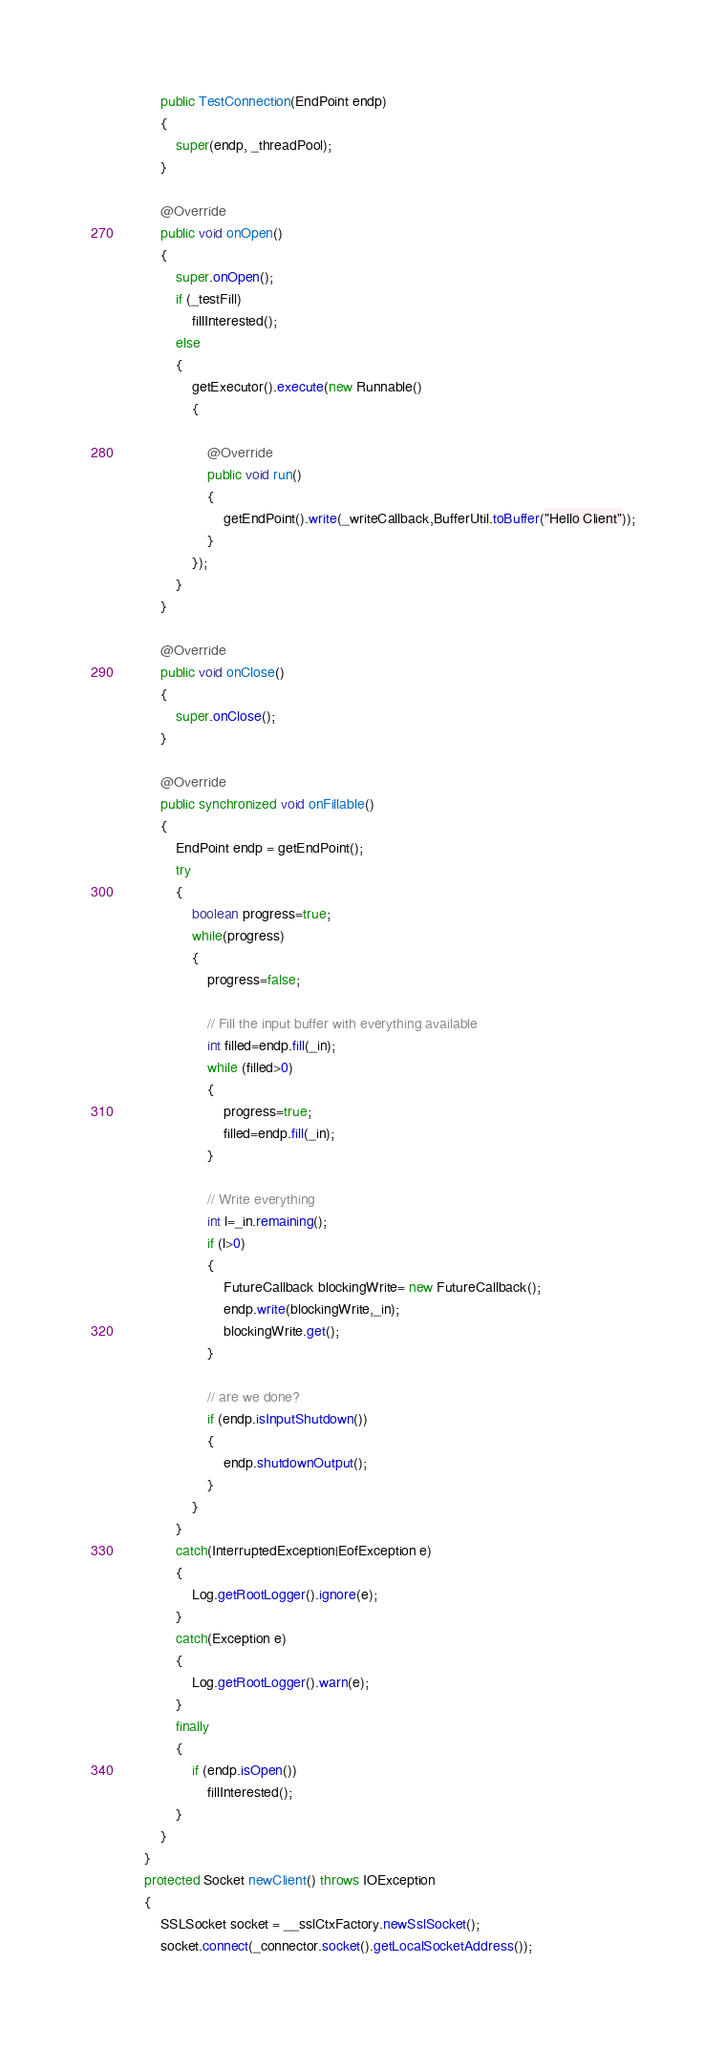<code> <loc_0><loc_0><loc_500><loc_500><_Java_>
        public TestConnection(EndPoint endp)
        {
            super(endp, _threadPool);
        }

        @Override
        public void onOpen()
        {
            super.onOpen();
            if (_testFill)
                fillInterested();
            else
            {
                getExecutor().execute(new Runnable()
                {

                    @Override
                    public void run()
                    {
                        getEndPoint().write(_writeCallback,BufferUtil.toBuffer("Hello Client"));
                    }
                });
            }
        }

        @Override
        public void onClose()
        {
            super.onClose();
        }

        @Override
        public synchronized void onFillable()
        {
            EndPoint endp = getEndPoint();
            try
            {
                boolean progress=true;
                while(progress)
                {
                    progress=false;

                    // Fill the input buffer with everything available
                    int filled=endp.fill(_in);
                    while (filled>0)
                    {
                        progress=true;
                        filled=endp.fill(_in);
                    }

                    // Write everything
                    int l=_in.remaining();
                    if (l>0)
                    {
                        FutureCallback blockingWrite= new FutureCallback();
                        endp.write(blockingWrite,_in);
                        blockingWrite.get();
                    }

                    // are we done?
                    if (endp.isInputShutdown())
                    {
                        endp.shutdownOutput();
                    }
                }
            }
            catch(InterruptedException|EofException e)
            {
                Log.getRootLogger().ignore(e);
            }
            catch(Exception e)
            {
                Log.getRootLogger().warn(e);
            }
            finally
            {
                if (endp.isOpen())
                    fillInterested();
            }
        }
    }
    protected Socket newClient() throws IOException
    {
        SSLSocket socket = __sslCtxFactory.newSslSocket();
        socket.connect(_connector.socket().getLocalSocketAddress());</code> 